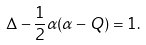Convert formula to latex. <formula><loc_0><loc_0><loc_500><loc_500>\Delta - \frac { 1 } { 2 } \alpha ( \alpha - Q ) = 1 .</formula> 